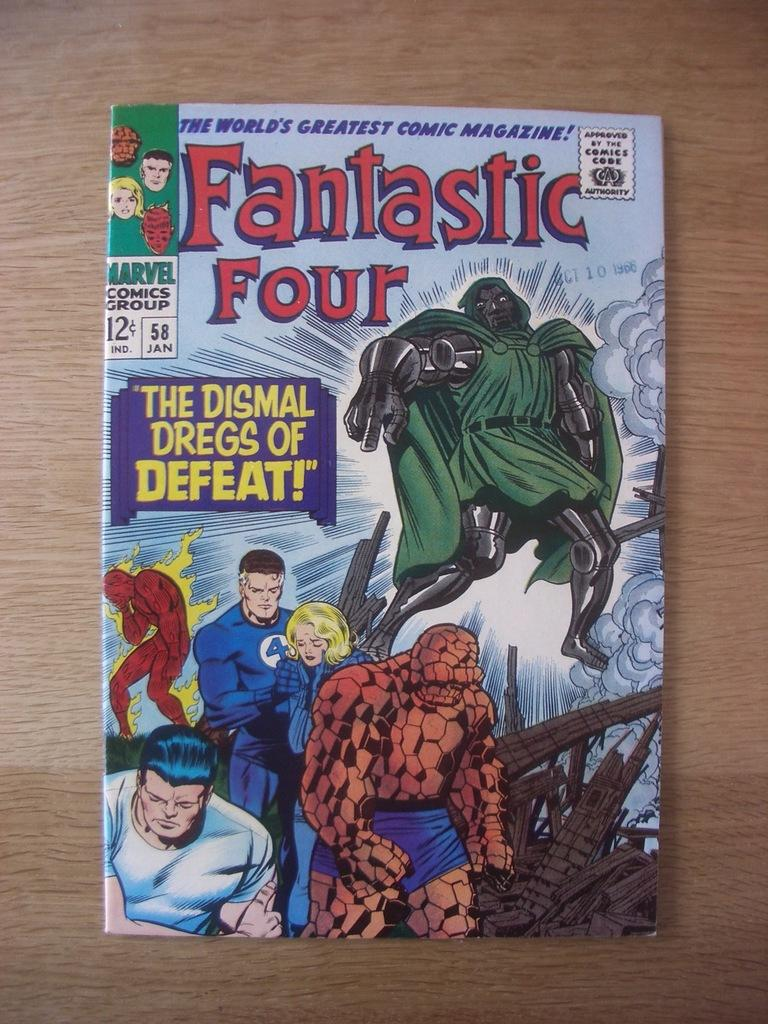<image>
Relay a brief, clear account of the picture shown. A Fantastic Four comic called "The Dismal Dregs of Defeat!" lies on a wooden table. 